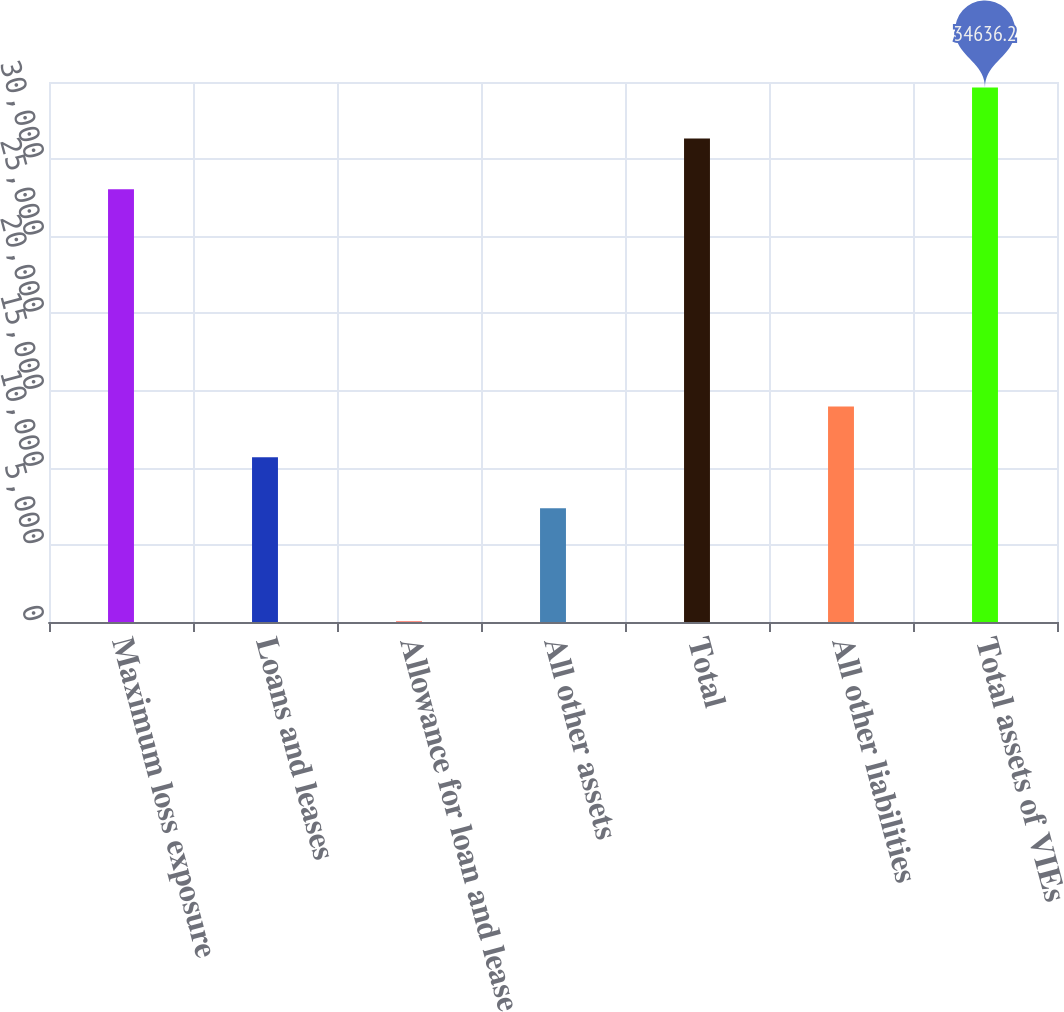<chart> <loc_0><loc_0><loc_500><loc_500><bar_chart><fcel>Maximum loss exposure<fcel>Loans and leases<fcel>Allowance for loan and lease<fcel>All other assets<fcel>Total<fcel>All other liabilities<fcel>Total assets of VIEs<nl><fcel>28044<fcel>10673.1<fcel>49<fcel>7377<fcel>31340.1<fcel>13969.2<fcel>34636.2<nl></chart> 